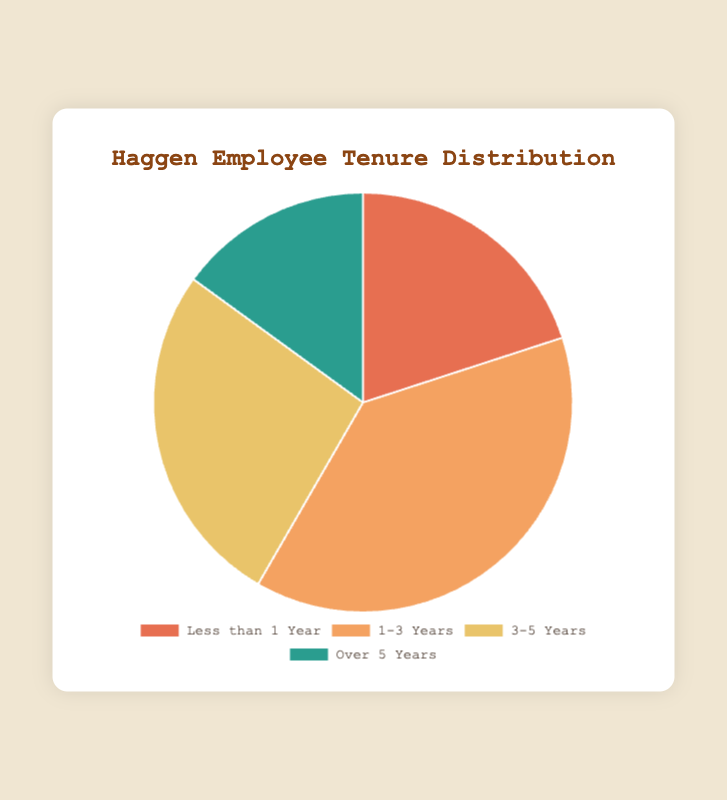What percentage of employees have been at Haggen for less than 1 year? There are 120 employees in the "Less than 1 Year" category. The total number of employees is 600 (120 + 230 + 160 + 90). The percentage is (120 / 600) * 100 = 20%.
Answer: 20% Which tenure category has the highest number of employees? The "1-3 Years" category has 230 employees, which is the highest among all categories.
Answer: 1-3 Years How many more employees are in the "1-3 Years" category compared to the "Over 5 Years" category? The "1-3 Years" category has 230 employees, and the "Over 5 Years" category has 90 employees. The difference is 230 - 90 = 140.
Answer: 140 What is the total number of employees with 3 or more years of tenure? Employees with "3-5 Years" and "Over 5 Years" tenures total 160 + 90 = 250.
Answer: 250 Which tenure category is represented by the green segment in the pie chart? The green segment represents the "Over 5 Years" category as per the color scheme provided.
Answer: Over 5 Years What is the ratio of employees with 1-3 years of tenure to those with less than 1 year of tenure? The number of employees with 1-3 years of tenure is 230 and those with less than 1 year of tenure is 120. The ratio is 230:120, which simplifies to 23:12.
Answer: 23:12 By how much does the number of employees in the "3-5 Years" category exceed the number in the "Over 5 Years" category? There are 160 employees in the "3-5 Years" category and 90 in the "Over 5 Years" category. The difference is 160 - 90 = 70.
Answer: 70 What proportion of employees have been at Haggen for more than 3 years? Employees who have been there for "3-5 Years" (160) and "Over 5 Years" (90) total 250. The proportion is 250 / 600 = 0.4167, or approximately 41.67%.
Answer: 41.67% How many employees are there on average in each tenure category? The total number of employees is 600, divided by 4 categories: 600 / 4 = 150.
Answer: 150 If the percentage of employees in the "1-3 Years" category is suddenly doubled, what would be the new total number of employees in this category? Currently, 230 employees make up 38.33% (230 / 600 * 100). Doubling this percentage means the new percentage would be 76.66%. Thus, the new number is 76.66% of 600, which is 0.7666 * 600 = 460.
Answer: 460 